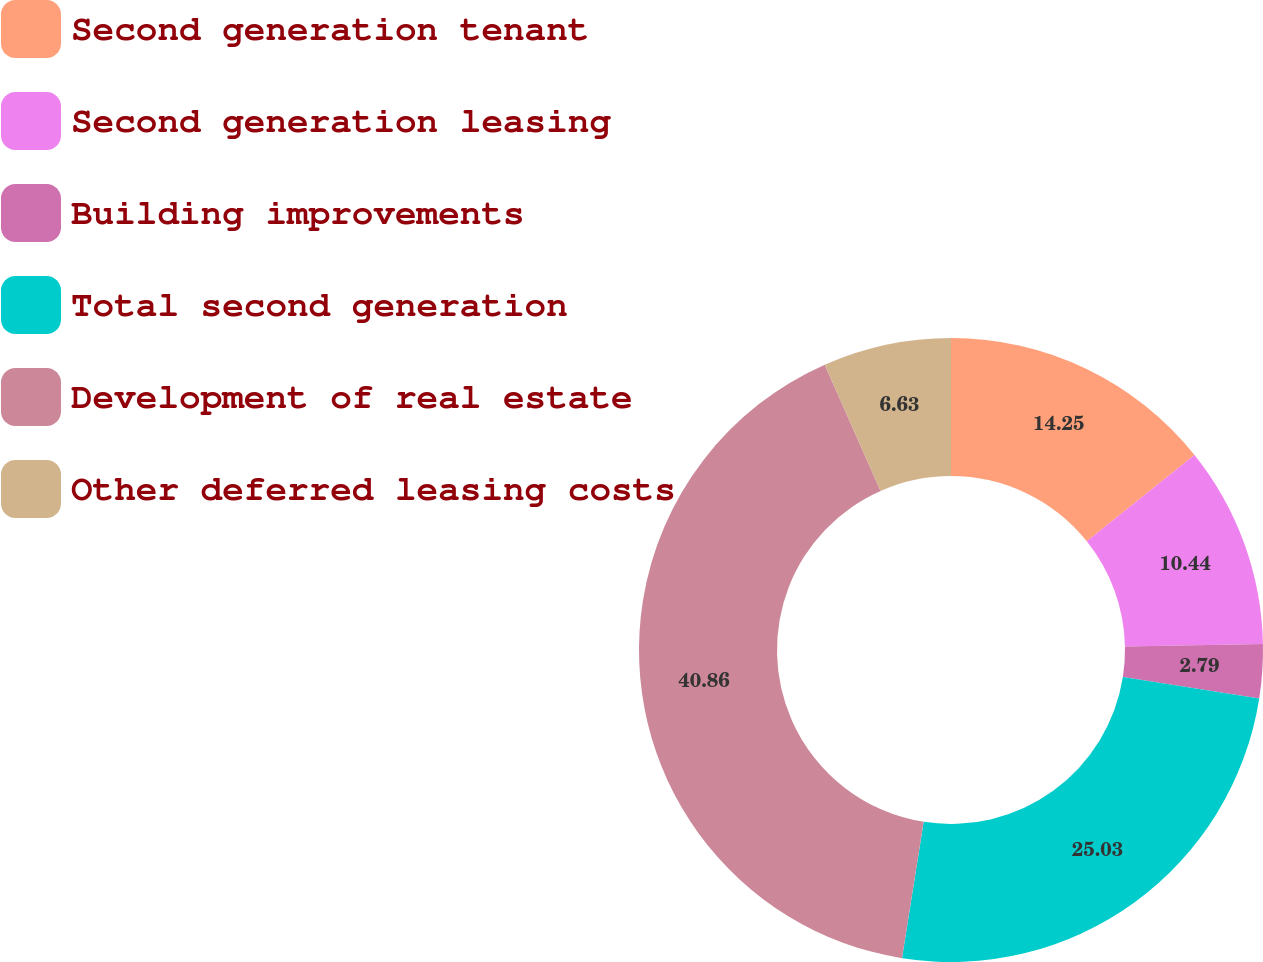Convert chart. <chart><loc_0><loc_0><loc_500><loc_500><pie_chart><fcel>Second generation tenant<fcel>Second generation leasing<fcel>Building improvements<fcel>Total second generation<fcel>Development of real estate<fcel>Other deferred leasing costs<nl><fcel>14.25%<fcel>10.44%<fcel>2.79%<fcel>25.03%<fcel>40.86%<fcel>6.63%<nl></chart> 